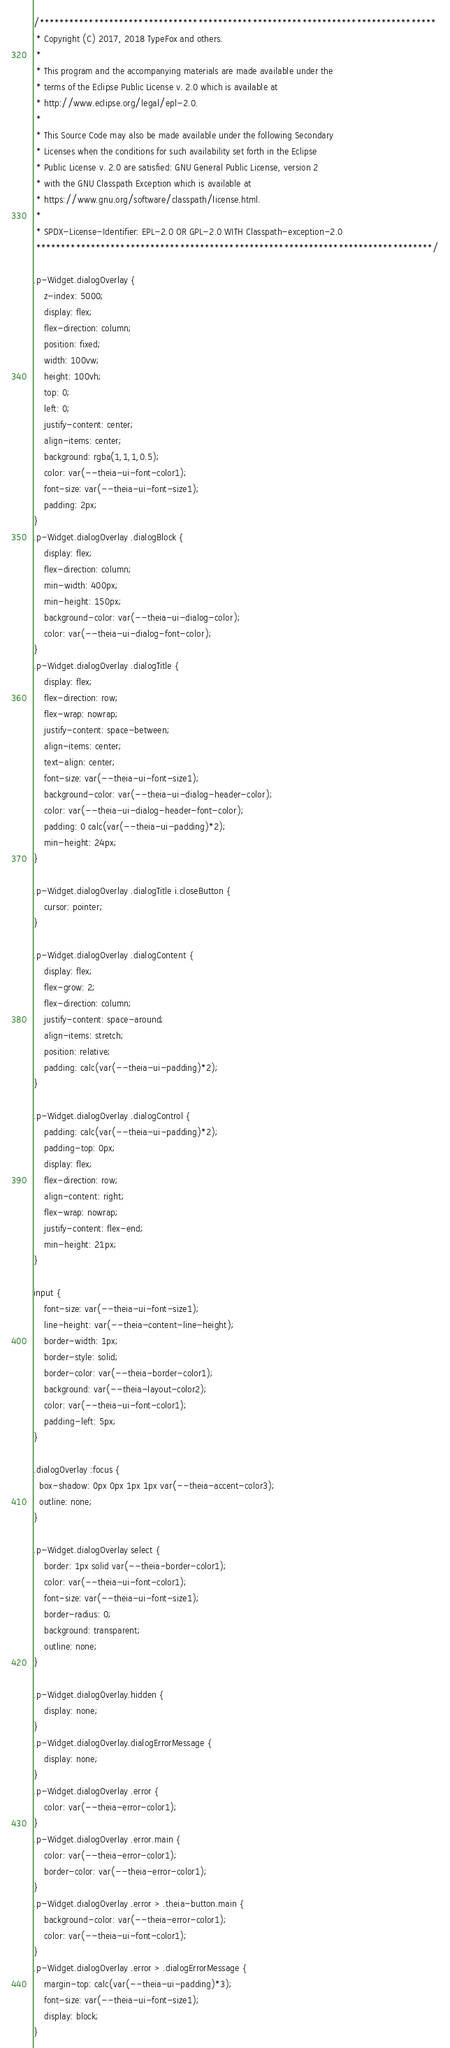<code> <loc_0><loc_0><loc_500><loc_500><_CSS_>/********************************************************************************
 * Copyright (C) 2017, 2018 TypeFox and others.
 *
 * This program and the accompanying materials are made available under the
 * terms of the Eclipse Public License v. 2.0 which is available at
 * http://www.eclipse.org/legal/epl-2.0.
 *
 * This Source Code may also be made available under the following Secondary
 * Licenses when the conditions for such availability set forth in the Eclipse
 * Public License v. 2.0 are satisfied: GNU General Public License, version 2
 * with the GNU Classpath Exception which is available at
 * https://www.gnu.org/software/classpath/license.html.
 *
 * SPDX-License-Identifier: EPL-2.0 OR GPL-2.0 WITH Classpath-exception-2.0
 ********************************************************************************/

.p-Widget.dialogOverlay {
    z-index: 5000;
    display: flex;
    flex-direction: column;
    position: fixed;
    width: 100vw;
    height: 100vh;
    top: 0;
    left: 0;
    justify-content: center;
    align-items: center;
    background: rgba(1,1,1,0.5);
    color: var(--theia-ui-font-color1);
    font-size: var(--theia-ui-font-size1);
    padding: 2px;
}
.p-Widget.dialogOverlay .dialogBlock {
    display: flex;
    flex-direction: column;
    min-width: 400px;
    min-height: 150px;
    background-color: var(--theia-ui-dialog-color);
    color: var(--theia-ui-dialog-font-color);
}
.p-Widget.dialogOverlay .dialogTitle {
    display: flex;
    flex-direction: row;
    flex-wrap: nowrap;
    justify-content: space-between;
    align-items: center;
    text-align: center;
    font-size: var(--theia-ui-font-size1);
    background-color: var(--theia-ui-dialog-header-color);
    color: var(--theia-ui-dialog-header-font-color);
    padding: 0 calc(var(--theia-ui-padding)*2);
    min-height: 24px;
}

.p-Widget.dialogOverlay .dialogTitle i.closeButton {
    cursor: pointer;
}

.p-Widget.dialogOverlay .dialogContent {
    display: flex;
    flex-grow: 2;
    flex-direction: column;
    justify-content: space-around;
    align-items: stretch;
    position: relative;
    padding: calc(var(--theia-ui-padding)*2);
}

.p-Widget.dialogOverlay .dialogControl {
    padding: calc(var(--theia-ui-padding)*2);
    padding-top: 0px;
    display: flex;
    flex-direction: row;
    align-content: right;
    flex-wrap: nowrap;
    justify-content: flex-end;
    min-height: 21px;
}

input {
    font-size: var(--theia-ui-font-size1);
    line-height: var(--theia-content-line-height);
    border-width: 1px;
    border-style: solid;
    border-color: var(--theia-border-color1);
    background: var(--theia-layout-color2);
    color: var(--theia-ui-font-color1);
    padding-left: 5px;
}

.dialogOverlay :focus {
  box-shadow: 0px 0px 1px 1px var(--theia-accent-color3);
  outline: none;
}

.p-Widget.dialogOverlay select {
    border: 1px solid var(--theia-border-color1);
    color: var(--theia-ui-font-color1);
    font-size: var(--theia-ui-font-size1);
    border-radius: 0;
    background: transparent;
    outline: none;
}

.p-Widget.dialogOverlay.hidden {
    display: none;
}
.p-Widget.dialogOverlay.dialogErrorMessage {
    display: none;
}
.p-Widget.dialogOverlay .error {
    color: var(--theia-error-color1);
}
.p-Widget.dialogOverlay .error.main {
    color: var(--theia-error-color1);
    border-color: var(--theia-error-color1);
}
.p-Widget.dialogOverlay .error > .theia-button.main {
    background-color: var(--theia-error-color1);
    color: var(--theia-ui-font-color1);
}
.p-Widget.dialogOverlay .error > .dialogErrorMessage {
    margin-top: calc(var(--theia-ui-padding)*3);
    font-size: var(--theia-ui-font-size1);
    display: block;
}
</code> 